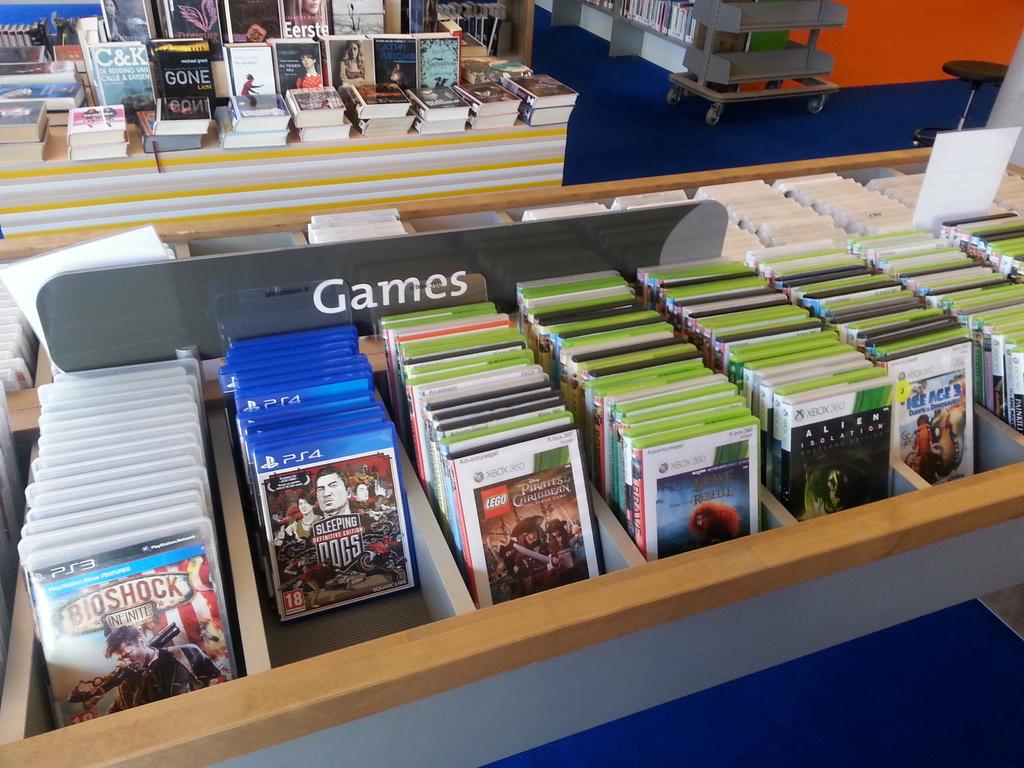What section of the store is that?
Your answer should be very brief. Games. What is the name of the first ps4 game?
Offer a terse response. Sleeping dogs. 